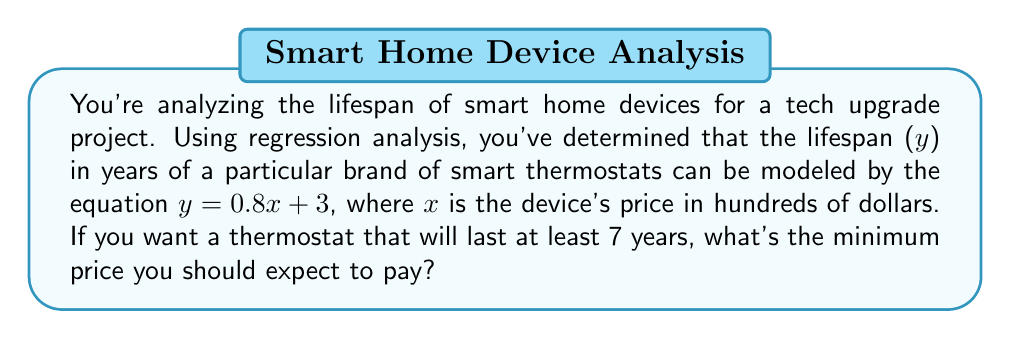Provide a solution to this math problem. Let's approach this step-by-step:

1) We're given the linear equation: $y = 0.8x + 3$
   Where y is the lifespan in years and x is the price in hundreds of dollars.

2) We want the lifespan (y) to be at least 7 years. So we can set up the inequality:
   $y \geq 7$

3) Substituting our equation:
   $0.8x + 3 \geq 7$

4) Subtract 3 from both sides:
   $0.8x \geq 4$

5) Divide both sides by 0.8:
   $x \geq 5$

6) Remember, x is in hundreds of dollars. So we need to multiply by 100:
   $100x \geq 500$

Therefore, you should expect to pay at least $500 for a smart thermostat that will last 7 years or more.
Answer: $500 